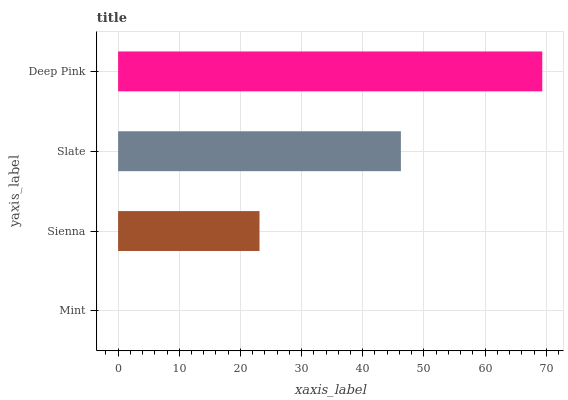Is Mint the minimum?
Answer yes or no. Yes. Is Deep Pink the maximum?
Answer yes or no. Yes. Is Sienna the minimum?
Answer yes or no. No. Is Sienna the maximum?
Answer yes or no. No. Is Sienna greater than Mint?
Answer yes or no. Yes. Is Mint less than Sienna?
Answer yes or no. Yes. Is Mint greater than Sienna?
Answer yes or no. No. Is Sienna less than Mint?
Answer yes or no. No. Is Slate the high median?
Answer yes or no. Yes. Is Sienna the low median?
Answer yes or no. Yes. Is Sienna the high median?
Answer yes or no. No. Is Mint the low median?
Answer yes or no. No. 